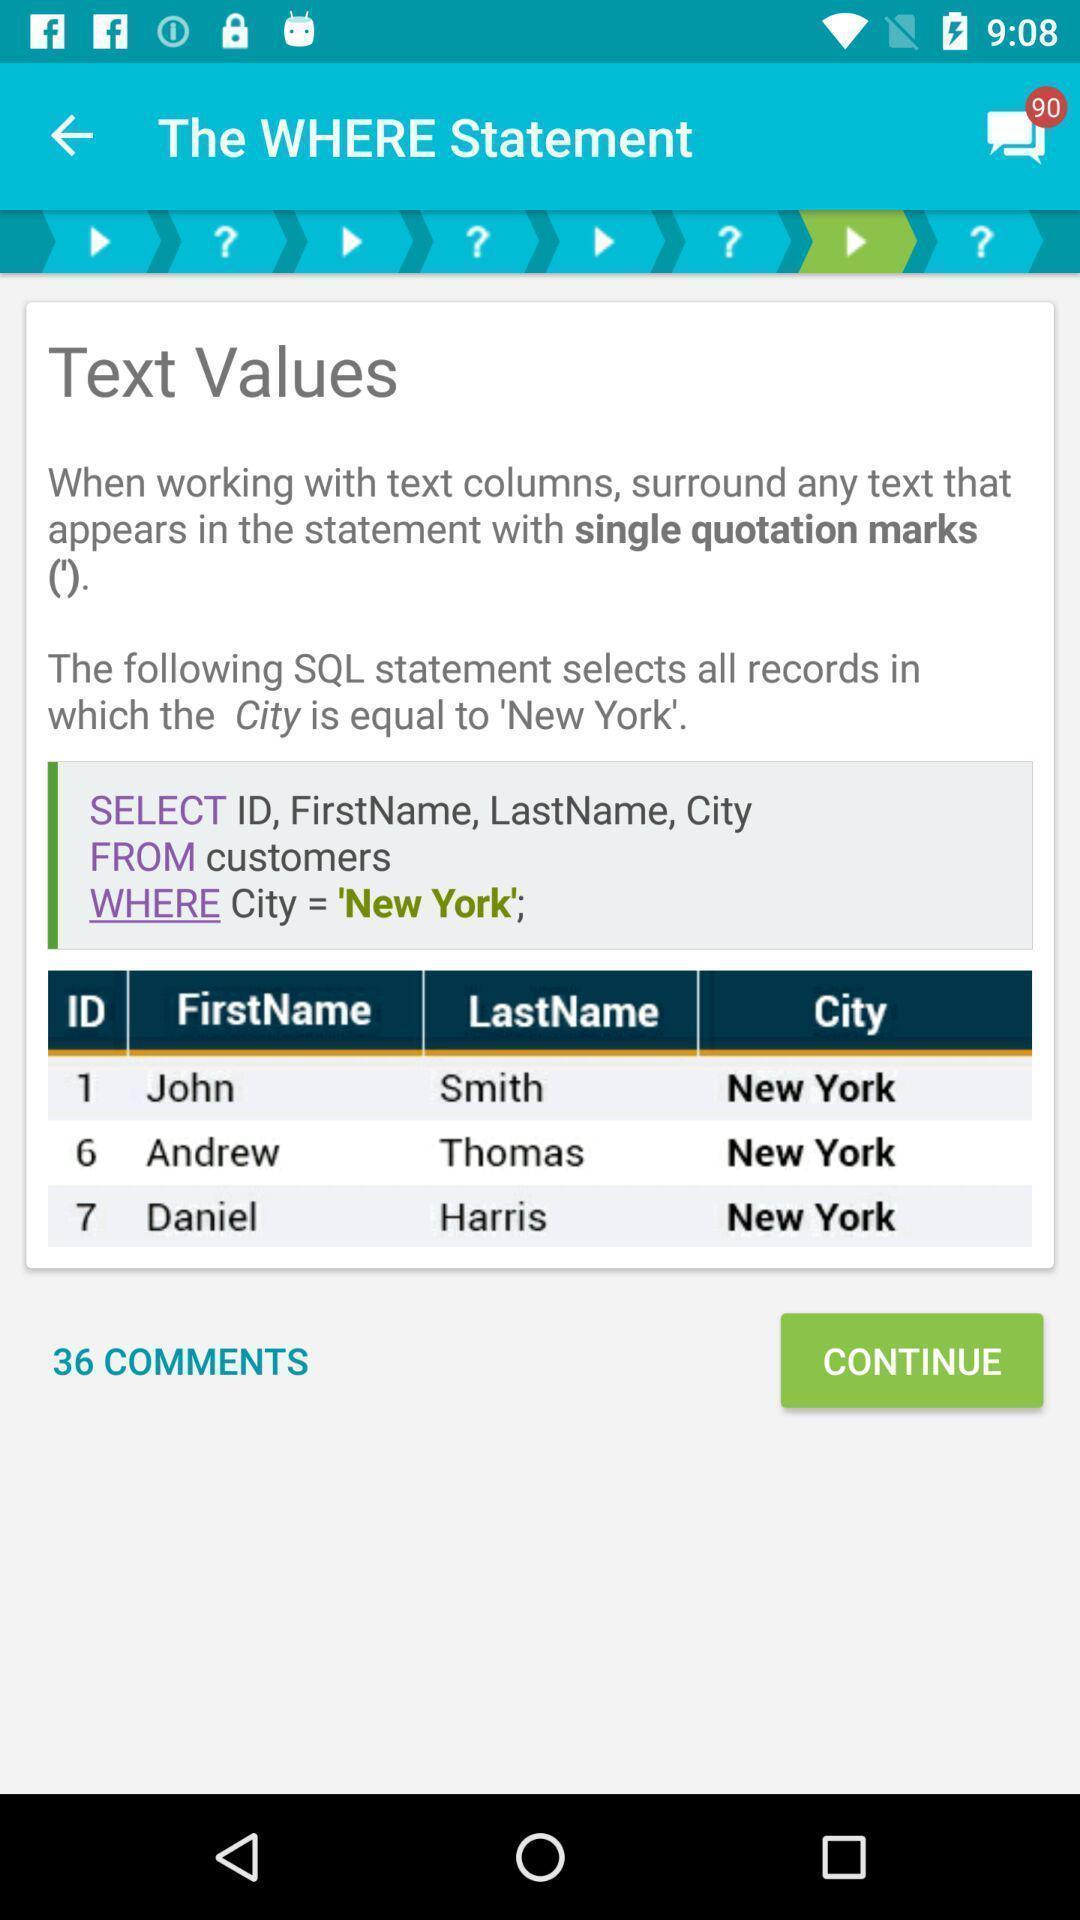Summarize the main components in this picture. Screen showing text values. 